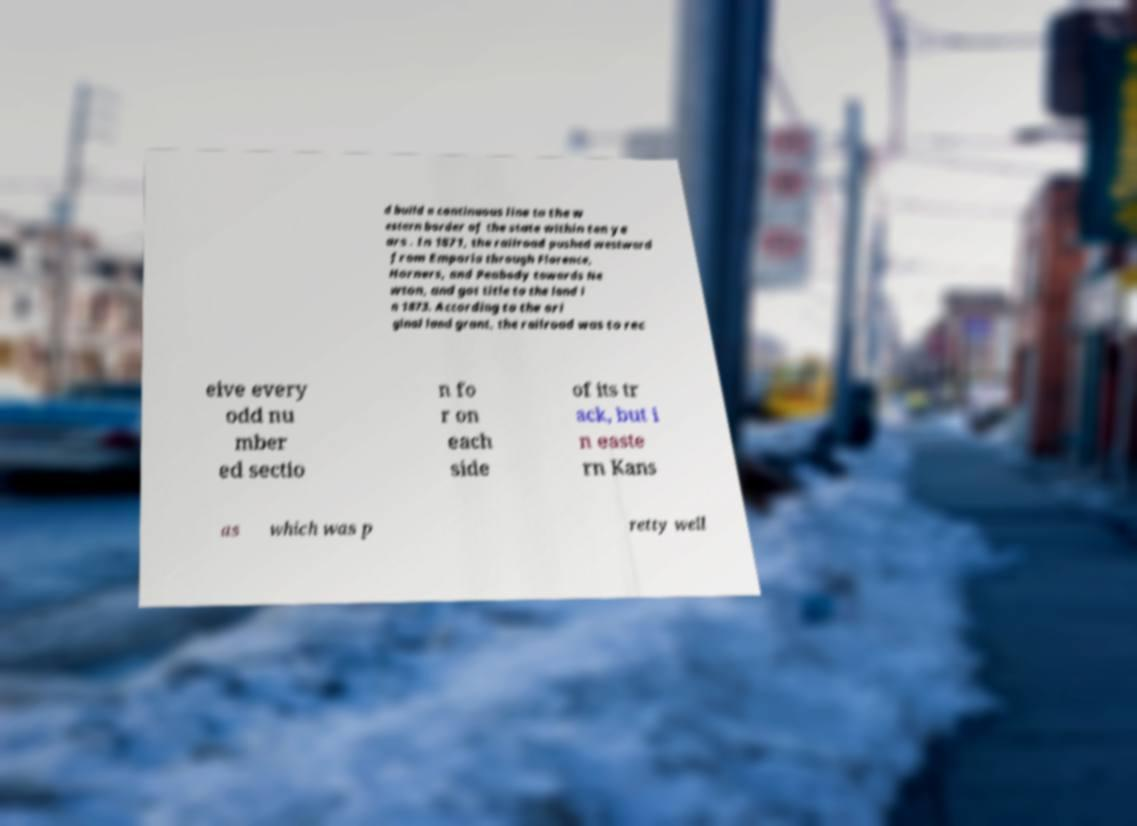Can you read and provide the text displayed in the image?This photo seems to have some interesting text. Can you extract and type it out for me? d build a continuous line to the w estern border of the state within ten ye ars . In 1871, the railroad pushed westward from Emporia through Florence, Horners, and Peabody towards Ne wton, and got title to the land i n 1873. According to the ori ginal land grant, the railroad was to rec eive every odd nu mber ed sectio n fo r on each side of its tr ack, but i n easte rn Kans as which was p retty well 